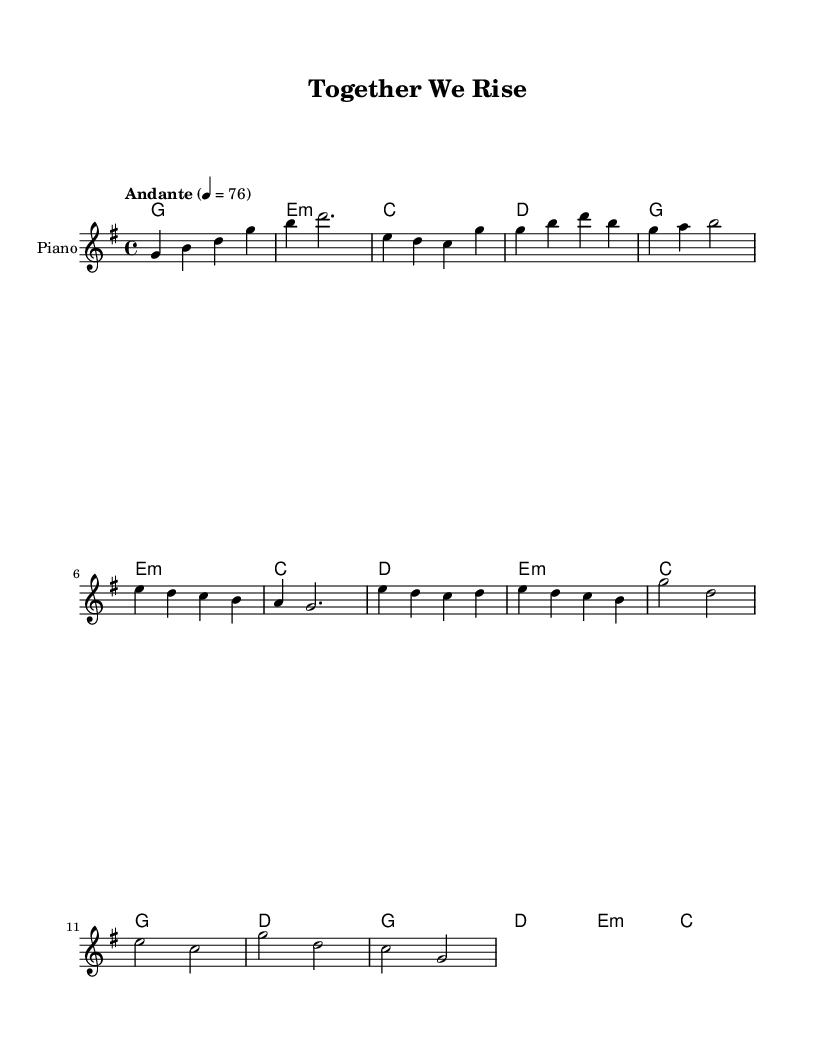What is the key signature of this music? The key signature is G major, which has one sharp (F#). This can be identified from the global settings, where it indicates the piece is in G major.
Answer: G major What is the time signature of this piece? The time signature is 4/4, which is specified in the global settings. This indicates that there are four beats per measure, with a quarter note receiving one beat.
Answer: 4/4 What is the tempo marking for this composition? The tempo marking is "Andante," with a speed indication of 4 = 76. This means the piece should be played at a moderate pace.
Answer: Andante How many measures does the chorus section contain? The chorus section consists of four measures, as identified by looking at the portion of the music indicated as the chorus, which has four distinct musical phrases.
Answer: 4 What is the primary theme expressed in the lyrics? The primary theme of the lyrics is unity and community, as indicated by phrases such as "Together we rise" and "Our strength is in community." This conveys a message of collaboration and support.
Answer: Unity What is the role of harmonies in this piece? The harmonies provide a structural support for the melody, creating a fuller sound and enhancing the emotional impact of the lyrics. They serve to enrich the musical experience, particularly in passages like the chorus.
Answer: Support What K-Pop characteristic is reflected in the lyrical content? The lyrical content reflects the K-Pop characteristic of emphasizing social themes, such as unity and community spirit, which is common in many K-Pop ballads aimed at fostering connection among listeners.
Answer: Social themes 